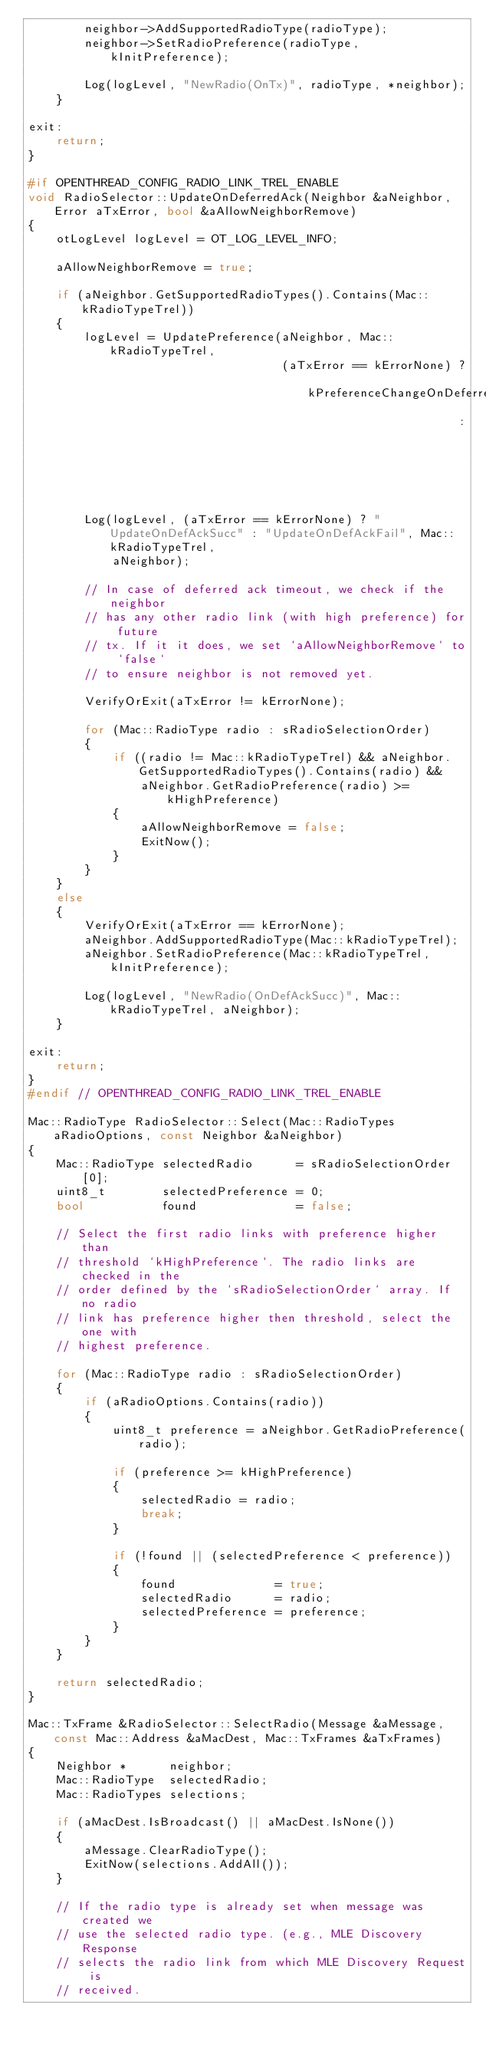<code> <loc_0><loc_0><loc_500><loc_500><_C++_>        neighbor->AddSupportedRadioType(radioType);
        neighbor->SetRadioPreference(radioType, kInitPreference);

        Log(logLevel, "NewRadio(OnTx)", radioType, *neighbor);
    }

exit:
    return;
}

#if OPENTHREAD_CONFIG_RADIO_LINK_TREL_ENABLE
void RadioSelector::UpdateOnDeferredAck(Neighbor &aNeighbor, Error aTxError, bool &aAllowNeighborRemove)
{
    otLogLevel logLevel = OT_LOG_LEVEL_INFO;

    aAllowNeighborRemove = true;

    if (aNeighbor.GetSupportedRadioTypes().Contains(Mac::kRadioTypeTrel))
    {
        logLevel = UpdatePreference(aNeighbor, Mac::kRadioTypeTrel,
                                    (aTxError == kErrorNone) ? kPreferenceChangeOnDeferredAckSuccess
                                                             : kPreferenceChangeOnDeferredAckTimeout);

        Log(logLevel, (aTxError == kErrorNone) ? "UpdateOnDefAckSucc" : "UpdateOnDefAckFail", Mac::kRadioTypeTrel,
            aNeighbor);

        // In case of deferred ack timeout, we check if the neighbor
        // has any other radio link (with high preference) for future
        // tx. If it it does, we set `aAllowNeighborRemove` to `false`
        // to ensure neighbor is not removed yet.

        VerifyOrExit(aTxError != kErrorNone);

        for (Mac::RadioType radio : sRadioSelectionOrder)
        {
            if ((radio != Mac::kRadioTypeTrel) && aNeighbor.GetSupportedRadioTypes().Contains(radio) &&
                aNeighbor.GetRadioPreference(radio) >= kHighPreference)
            {
                aAllowNeighborRemove = false;
                ExitNow();
            }
        }
    }
    else
    {
        VerifyOrExit(aTxError == kErrorNone);
        aNeighbor.AddSupportedRadioType(Mac::kRadioTypeTrel);
        aNeighbor.SetRadioPreference(Mac::kRadioTypeTrel, kInitPreference);

        Log(logLevel, "NewRadio(OnDefAckSucc)", Mac::kRadioTypeTrel, aNeighbor);
    }

exit:
    return;
}
#endif // OPENTHREAD_CONFIG_RADIO_LINK_TREL_ENABLE

Mac::RadioType RadioSelector::Select(Mac::RadioTypes aRadioOptions, const Neighbor &aNeighbor)
{
    Mac::RadioType selectedRadio      = sRadioSelectionOrder[0];
    uint8_t        selectedPreference = 0;
    bool           found              = false;

    // Select the first radio links with preference higher than
    // threshold `kHighPreference`. The radio links are checked in the
    // order defined by the `sRadioSelectionOrder` array. If no radio
    // link has preference higher then threshold, select the one with
    // highest preference.

    for (Mac::RadioType radio : sRadioSelectionOrder)
    {
        if (aRadioOptions.Contains(radio))
        {
            uint8_t preference = aNeighbor.GetRadioPreference(radio);

            if (preference >= kHighPreference)
            {
                selectedRadio = radio;
                break;
            }

            if (!found || (selectedPreference < preference))
            {
                found              = true;
                selectedRadio      = radio;
                selectedPreference = preference;
            }
        }
    }

    return selectedRadio;
}

Mac::TxFrame &RadioSelector::SelectRadio(Message &aMessage, const Mac::Address &aMacDest, Mac::TxFrames &aTxFrames)
{
    Neighbor *      neighbor;
    Mac::RadioType  selectedRadio;
    Mac::RadioTypes selections;

    if (aMacDest.IsBroadcast() || aMacDest.IsNone())
    {
        aMessage.ClearRadioType();
        ExitNow(selections.AddAll());
    }

    // If the radio type is already set when message was created we
    // use the selected radio type. (e.g., MLE Discovery Response
    // selects the radio link from which MLE Discovery Request is
    // received.
</code> 